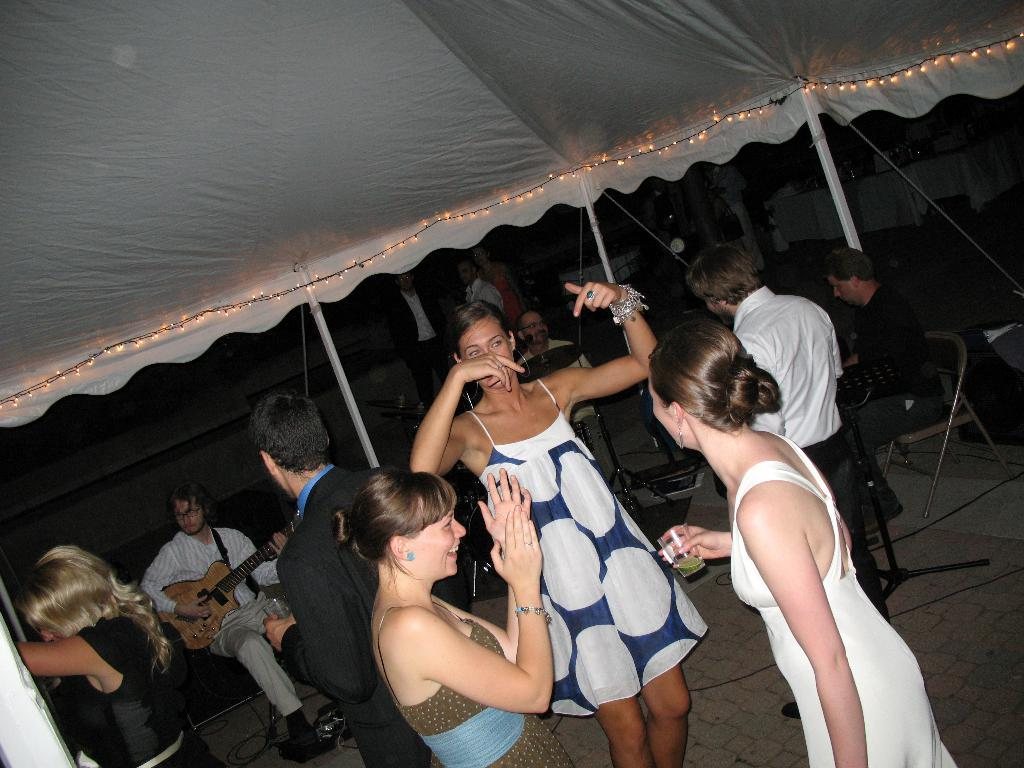What are the people in the image doing? The people in the image are playing musical instruments and dancing. How are the people interacting with the musicians? People are standing and dancing in front of the musicians. What structure can be seen in the image? There is a tent in the image. How far away are the people from the musicians? People are standing far from the musicians. What type of patch is sewn onto the room in the image? There is no patch or room present in the image; it features people playing musical instruments and dancing. 